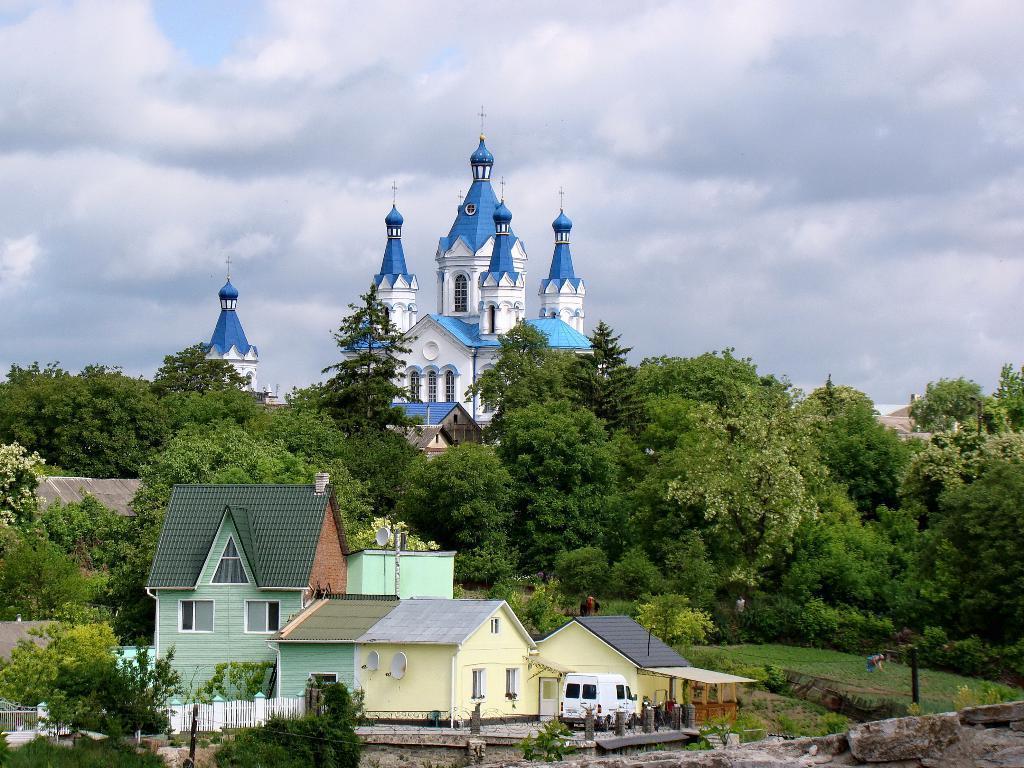How would you summarize this image in a sentence or two? In this image there is a car parked in front of a house, on the house there are antennas, beside the house there is a wooden fence, on the other side of the house there are two people on the grass and there is a metal rod an there are plants and bushes, in the background of the image there are trees and buildings, at the top of the image there are clouds in the sky. 